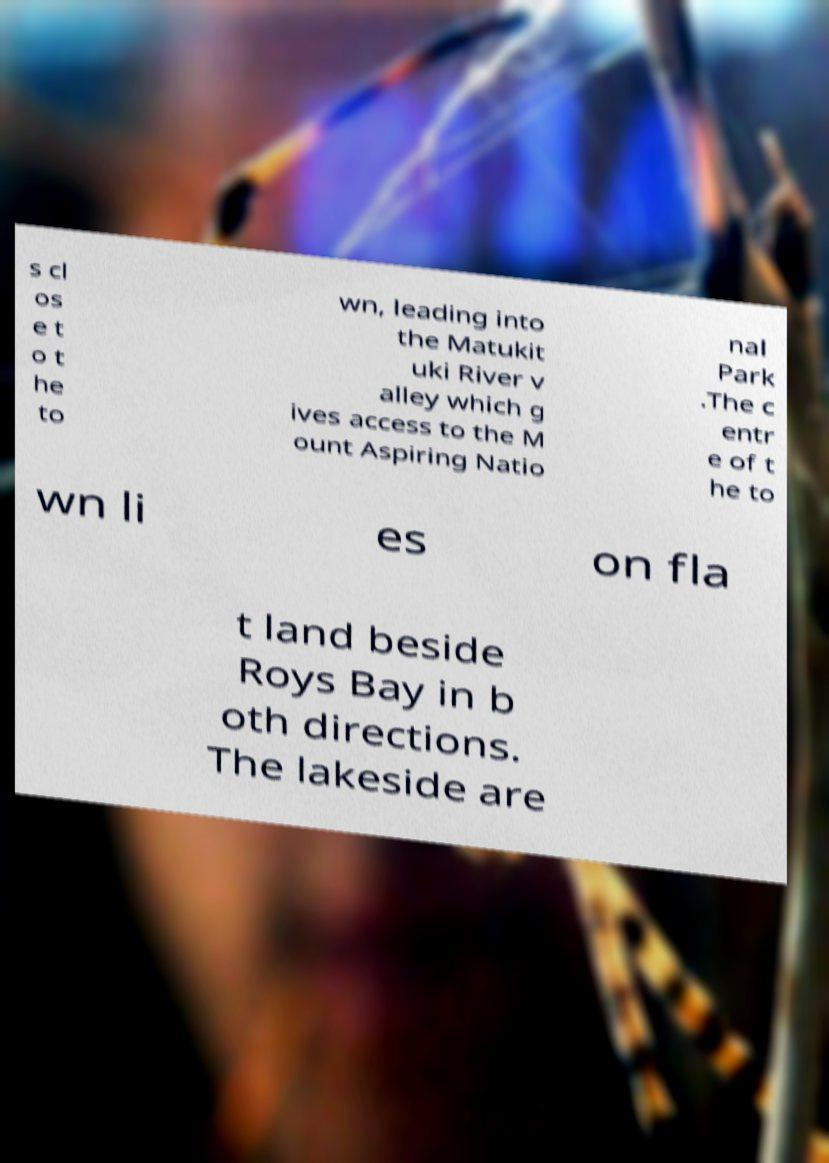What messages or text are displayed in this image? I need them in a readable, typed format. s cl os e t o t he to wn, leading into the Matukit uki River v alley which g ives access to the M ount Aspiring Natio nal Park .The c entr e of t he to wn li es on fla t land beside Roys Bay in b oth directions. The lakeside are 